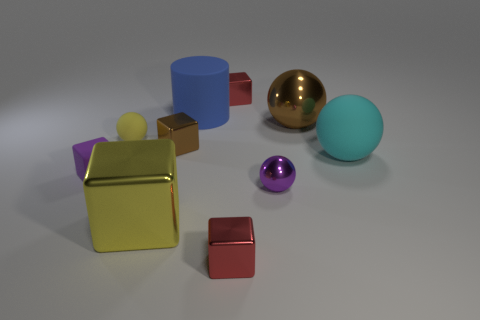Can you describe the positions of the different objects on the surface? Certainly! In the image, we see a variety of three-dimensional shapes arranged on a flat surface. Starting on the left, there is a large blue cylinder, followed by a large yellow cube with a matte finish. Positioned somewhat centrally is a large, shiny metallic sphere. To the right of the sphere, there is a smaller red cube and a tiny purple sphere, and finally on the far right, a light blue, matte-finish sphere. 